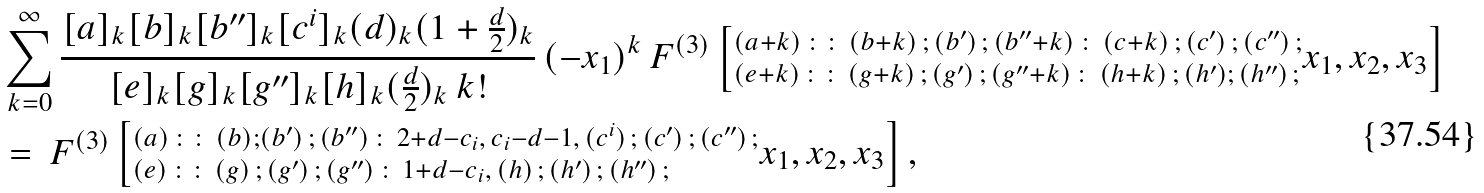<formula> <loc_0><loc_0><loc_500><loc_500>\ & \sum _ { k = 0 } ^ { \infty } \frac { [ a ] _ { k } [ b ] _ { k } [ b ^ { \prime \prime } ] _ { k } [ c ^ { i } ] _ { k } ( d ) _ { k } ( 1 + \frac { d } { 2 } ) _ { k } } { [ e ] _ { k } [ g ] _ { k } [ g ^ { \prime \prime } ] _ { k } [ h ] _ { k } ( \frac { d } { 2 } ) _ { k } \, k ! } \, ( - x _ { 1 } ) ^ { k } \, F ^ { ( 3 ) } \left [ ^ { ( a + k ) \, \colon \colon \, ( b + k ) \, ; \, ( b ^ { \prime } ) \, ; \, ( b ^ { \prime \prime } + k ) \, \colon \, ( c + k ) \, ; \, ( c ^ { \prime } ) \, ; \, ( c ^ { \prime \prime } ) \, ; } _ { ( e + k ) \, \colon \colon \, ( g + k ) \, ; \, ( g ^ { \prime } ) \, ; \, ( g ^ { \prime \prime } + k ) \, \colon \, ( h + k ) \, ; \, ( h ^ { \prime } ) ; \, ( h ^ { \prime \prime } ) \, ; } x _ { 1 } , x _ { 2 } , x _ { 3 } \right ] \\ & = \, F ^ { ( 3 ) } \left [ ^ { ( a ) \, \colon \colon \, ( b ) ; ( b ^ { \prime } ) \, ; \, ( b ^ { \prime \prime } ) \, \colon \, 2 + d - c _ { i } , \, c _ { i } - d - 1 , \, ( c ^ { i } ) \, ; \, ( c ^ { \prime } ) \, ; \, ( c ^ { \prime \prime } ) \, ; } _ { ( e ) \, \colon \colon \, ( g ) \, ; \, ( g ^ { \prime } ) \, ; \, ( g ^ { \prime \prime } ) \, \colon \, 1 + d - c _ { i } , \, ( h ) \, ; \, ( h ^ { \prime } ) \, ; \, ( h ^ { \prime \prime } ) \, ; } x _ { 1 } , x _ { 2 } , x _ { 3 } \right ] ,</formula> 